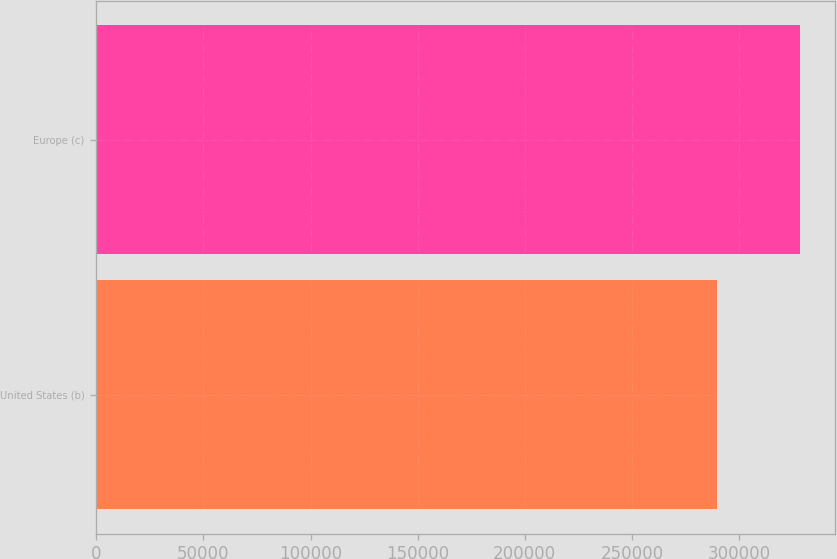<chart> <loc_0><loc_0><loc_500><loc_500><bar_chart><fcel>United States (b)<fcel>Europe (c)<nl><fcel>289875<fcel>328493<nl></chart> 